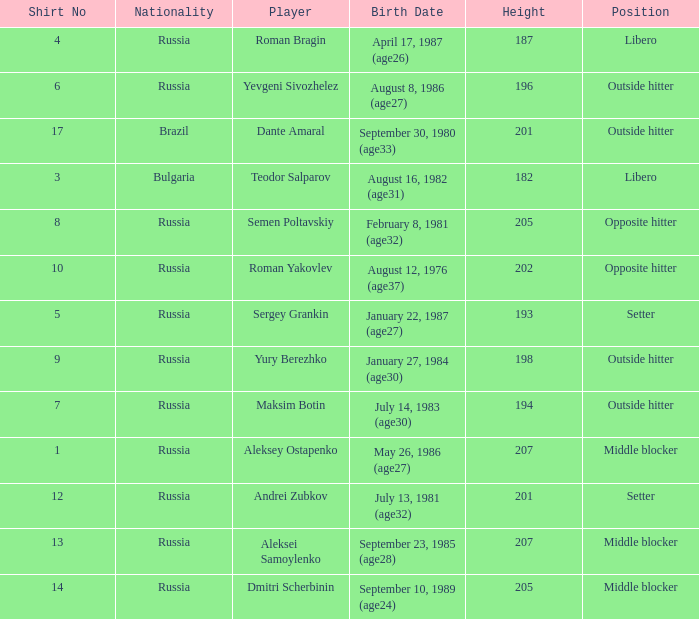How many position does Teodor Salparov play on?  1.0. 